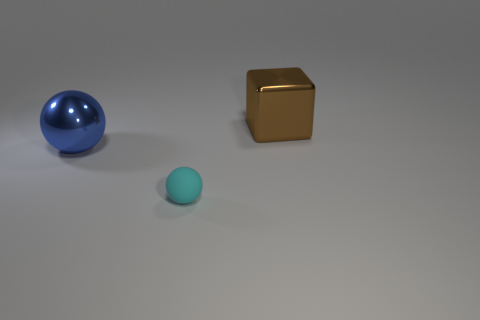Add 3 large blue balls. How many objects exist? 6 Subtract all blocks. How many objects are left? 2 Add 1 big green rubber cylinders. How many big green rubber cylinders exist? 1 Subtract 0 cyan cubes. How many objects are left? 3 Subtract all tiny cyan balls. Subtract all gray shiny things. How many objects are left? 2 Add 1 tiny things. How many tiny things are left? 2 